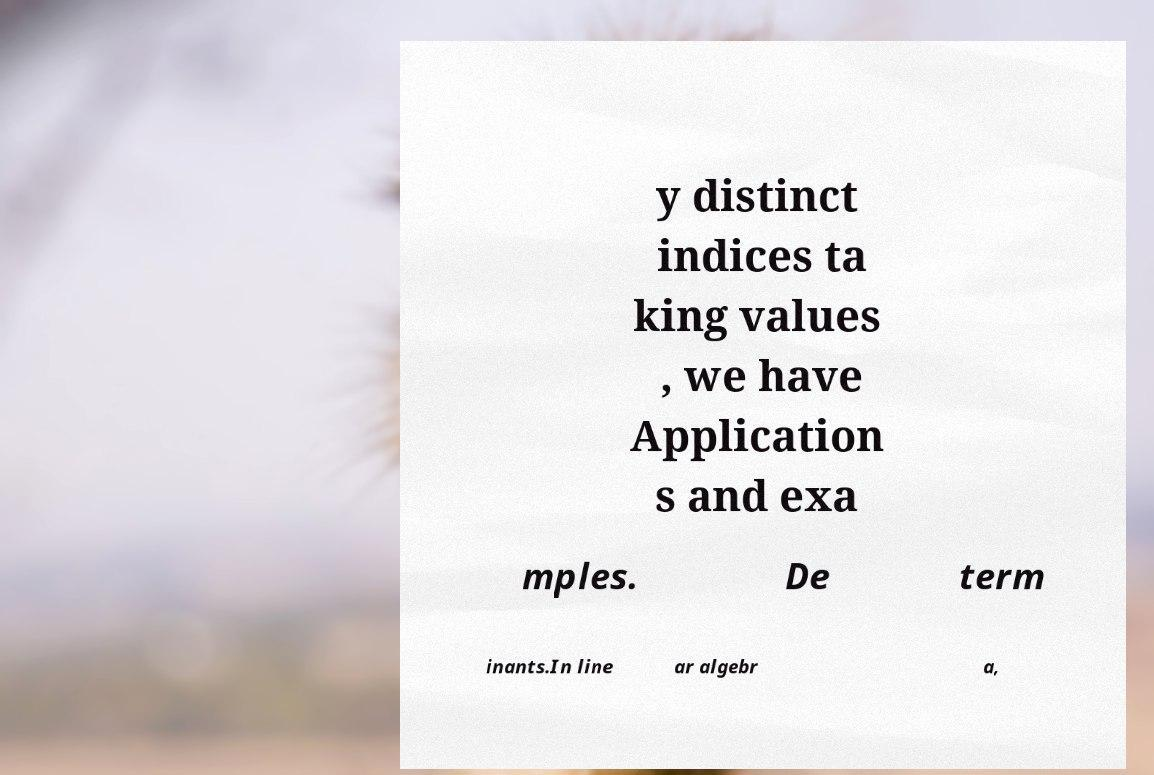Can you accurately transcribe the text from the provided image for me? y distinct indices ta king values , we have Application s and exa mples. De term inants.In line ar algebr a, 